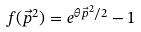<formula> <loc_0><loc_0><loc_500><loc_500>f ( \vec { p } ^ { 2 } ) = e ^ { \theta \vec { p } ^ { 2 } / 2 } - 1</formula> 